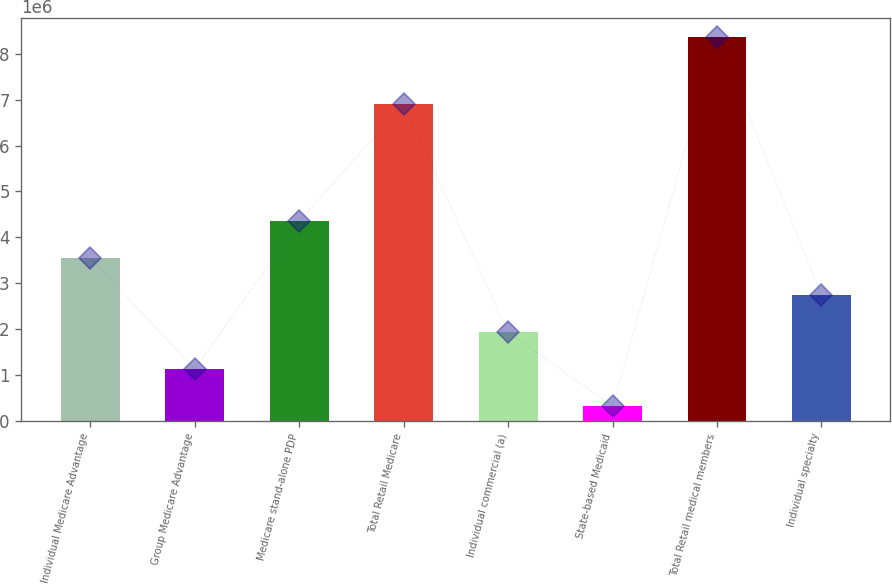<chart> <loc_0><loc_0><loc_500><loc_500><bar_chart><fcel>Individual Medicare Advantage<fcel>Group Medicare Advantage<fcel>Medicare stand-alone PDP<fcel>Total Retail Medicare<fcel>Individual commercial (a)<fcel>State-based Medicaid<fcel>Total Retail medical members<fcel>Individual specialty<nl><fcel>3.54068e+06<fcel>1.12277e+06<fcel>4.34665e+06<fcel>6.9116e+06<fcel>1.92874e+06<fcel>316800<fcel>8.3765e+06<fcel>2.73471e+06<nl></chart> 